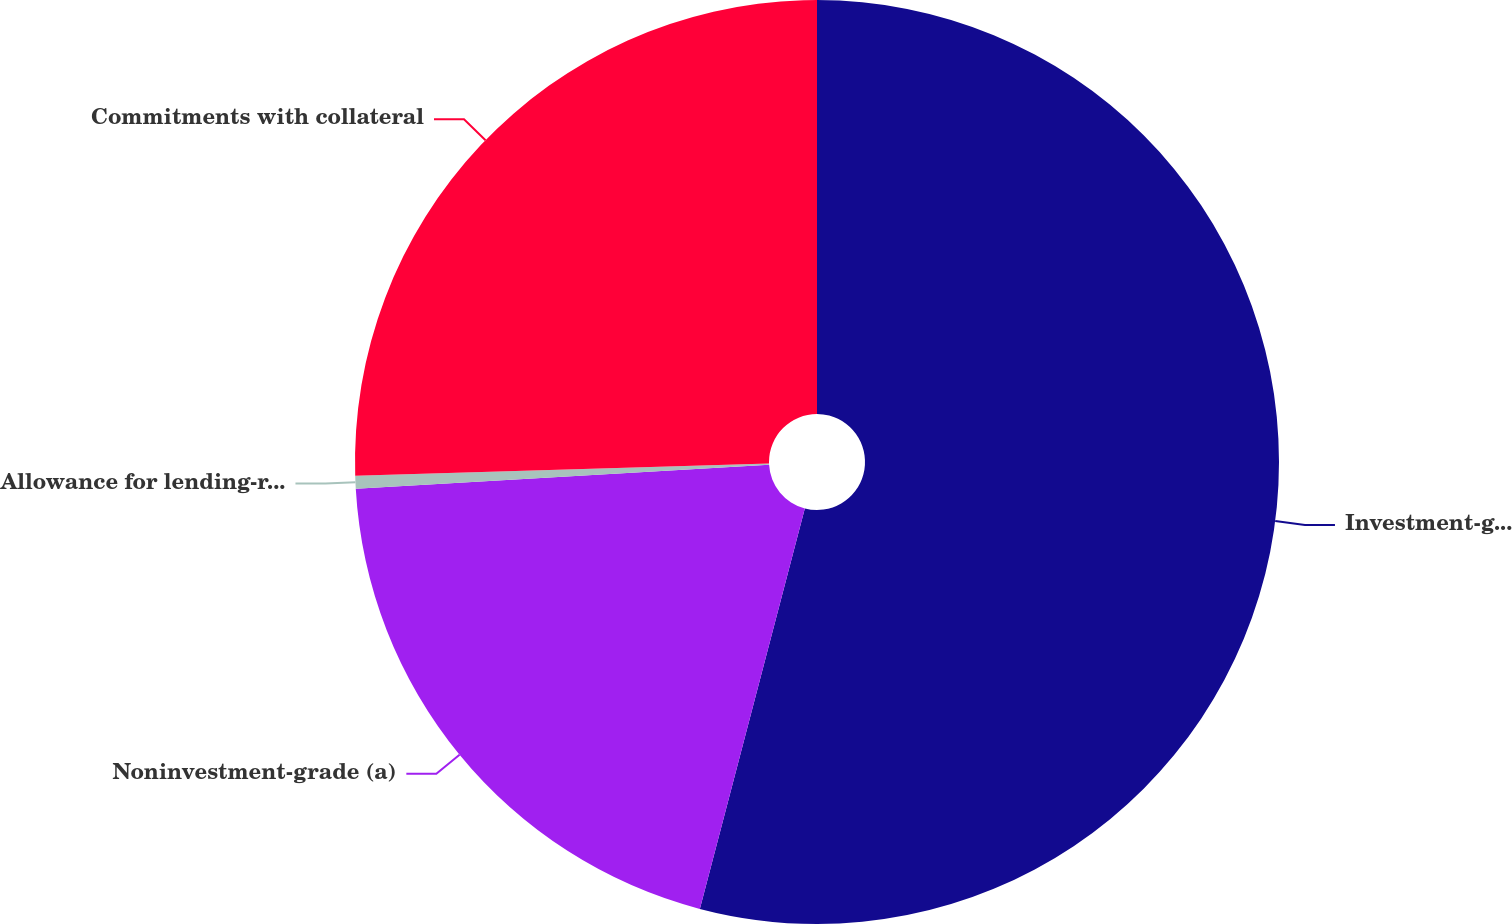<chart> <loc_0><loc_0><loc_500><loc_500><pie_chart><fcel>Investment-grade (a)<fcel>Noninvestment-grade (a)<fcel>Allowance for lending-related<fcel>Commitments with collateral<nl><fcel>54.08%<fcel>20.0%<fcel>0.45%<fcel>25.47%<nl></chart> 